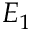Convert formula to latex. <formula><loc_0><loc_0><loc_500><loc_500>E _ { 1 }</formula> 